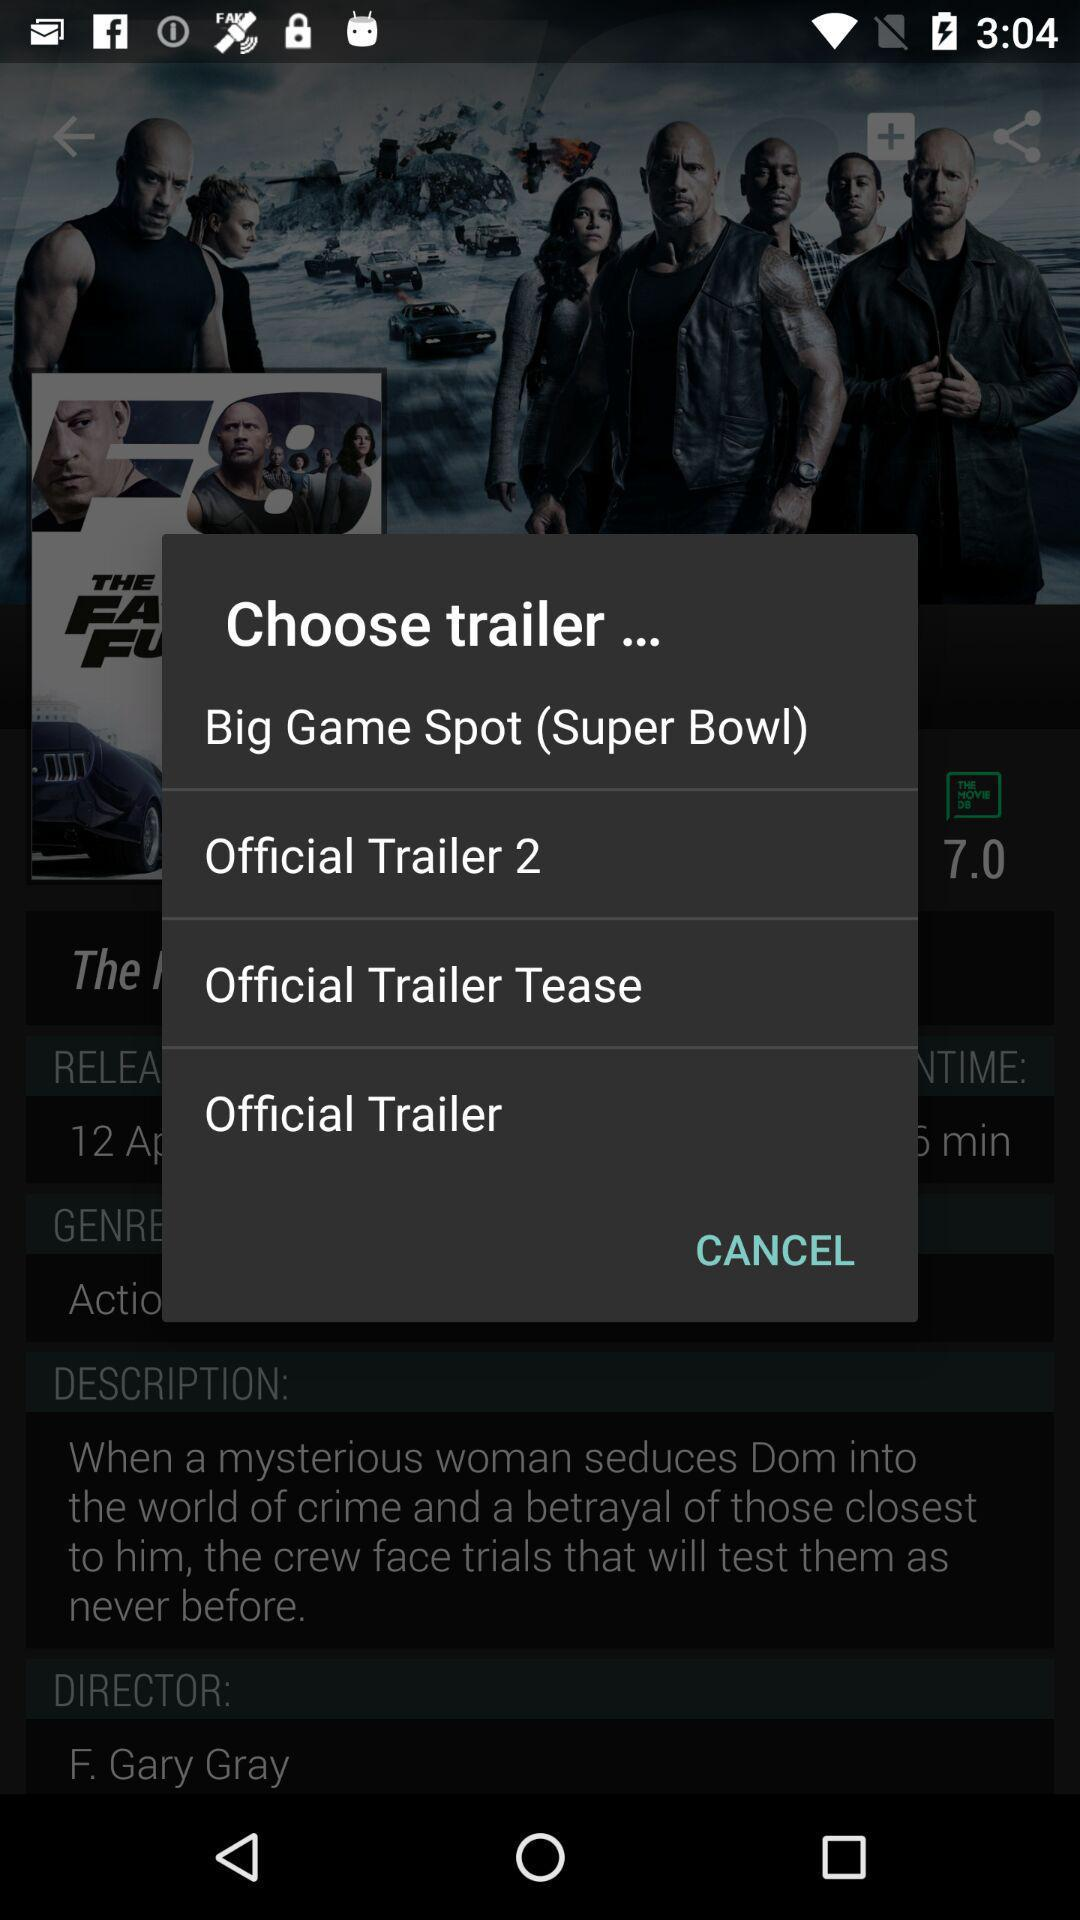How many trailers are available?
Answer the question using a single word or phrase. 4 